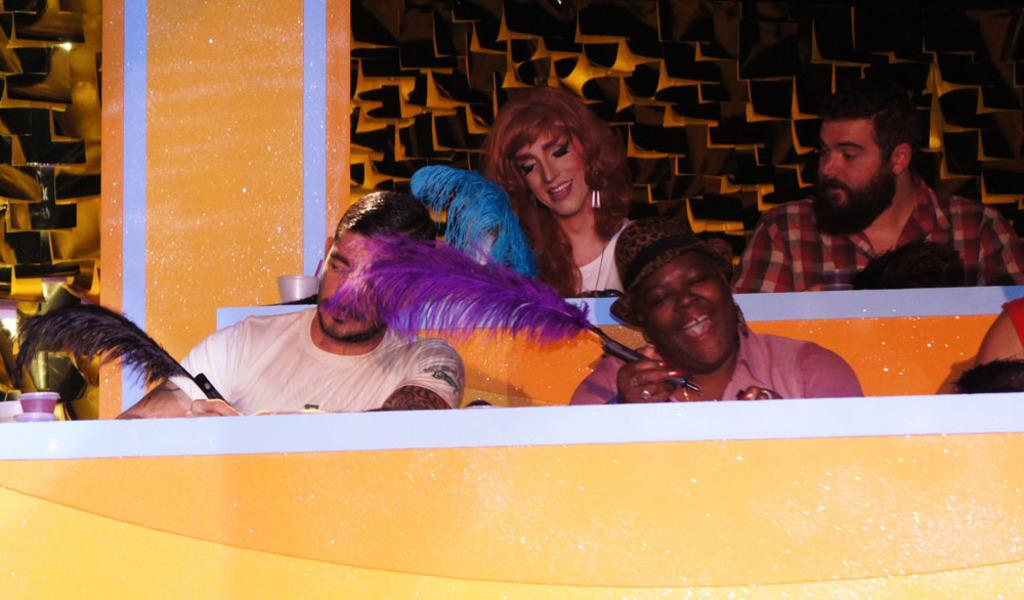What are the people in the image doing? The people in the image are sitting and holding pens. What objects can be seen near the people? Glasses are visible in the image. What architectural feature is present in the image? There is a pillar in the image. What can be seen in the background of the image? There is a design wall in the background of the image. What type of waves can be seen crashing against the shore in the image? There are no waves or shore visible in the image; it features people sitting with pens, glasses, a pillar, and a design wall in the background. 